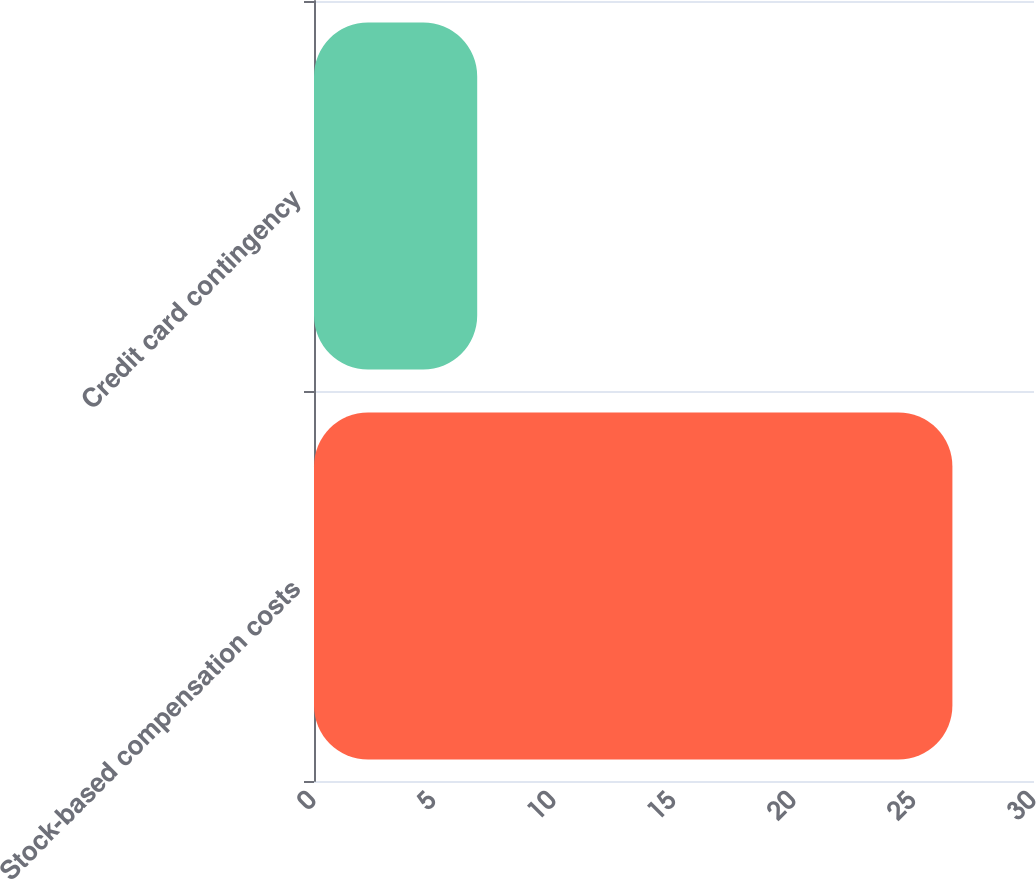Convert chart to OTSL. <chart><loc_0><loc_0><loc_500><loc_500><bar_chart><fcel>Stock-based compensation costs<fcel>Credit card contingency<nl><fcel>26.6<fcel>6.8<nl></chart> 